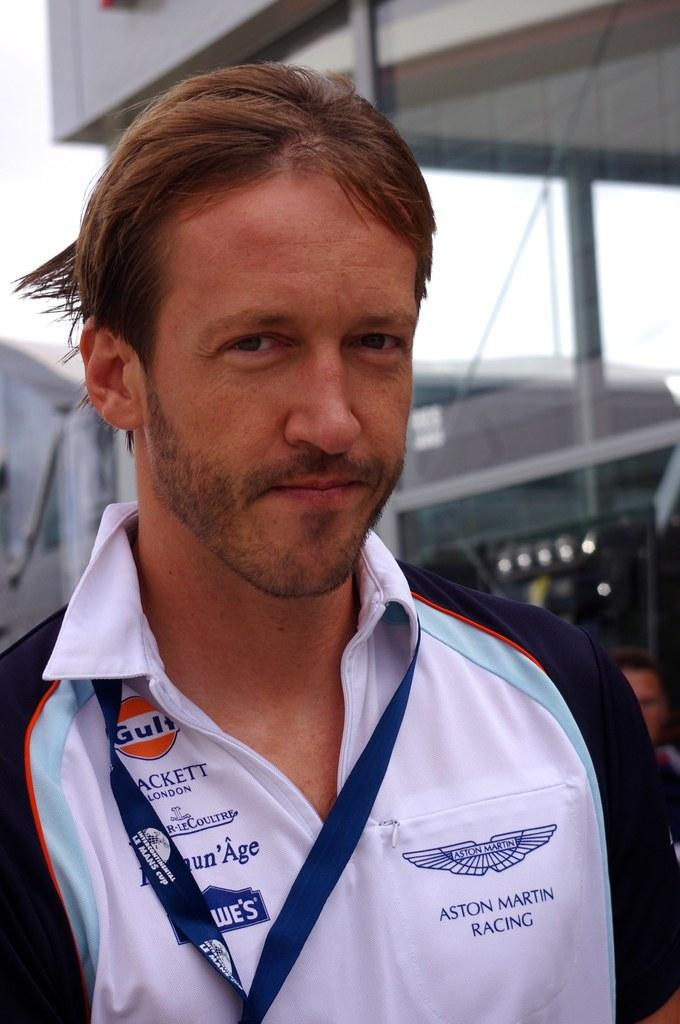<image>
Give a short and clear explanation of the subsequent image. A man with a white shirt that says Aston Martin Racing on the left side and Lowes on the left. 